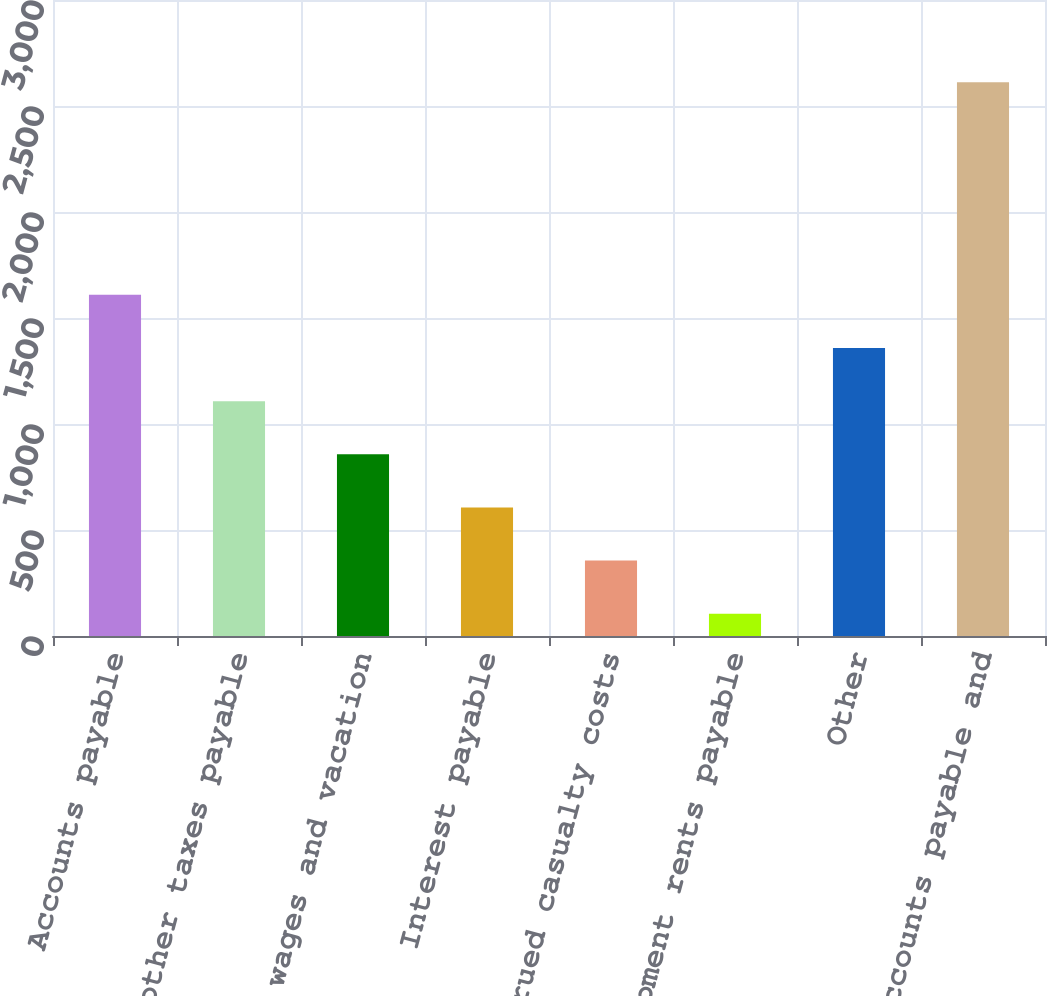Convert chart. <chart><loc_0><loc_0><loc_500><loc_500><bar_chart><fcel>Accounts payable<fcel>Income and other taxes payable<fcel>Accrued wages and vacation<fcel>Interest payable<fcel>Accrued casualty costs<fcel>Equipment rents payable<fcel>Other<fcel>Total accounts payable and<nl><fcel>1609.2<fcel>1107.8<fcel>857.1<fcel>606.4<fcel>355.7<fcel>105<fcel>1358.5<fcel>2612<nl></chart> 